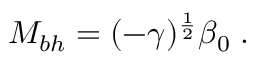Convert formula to latex. <formula><loc_0><loc_0><loc_500><loc_500>M _ { b h } = ( - \gamma ) ^ { \frac { 1 } { 2 } } \beta _ { 0 } \, .</formula> 